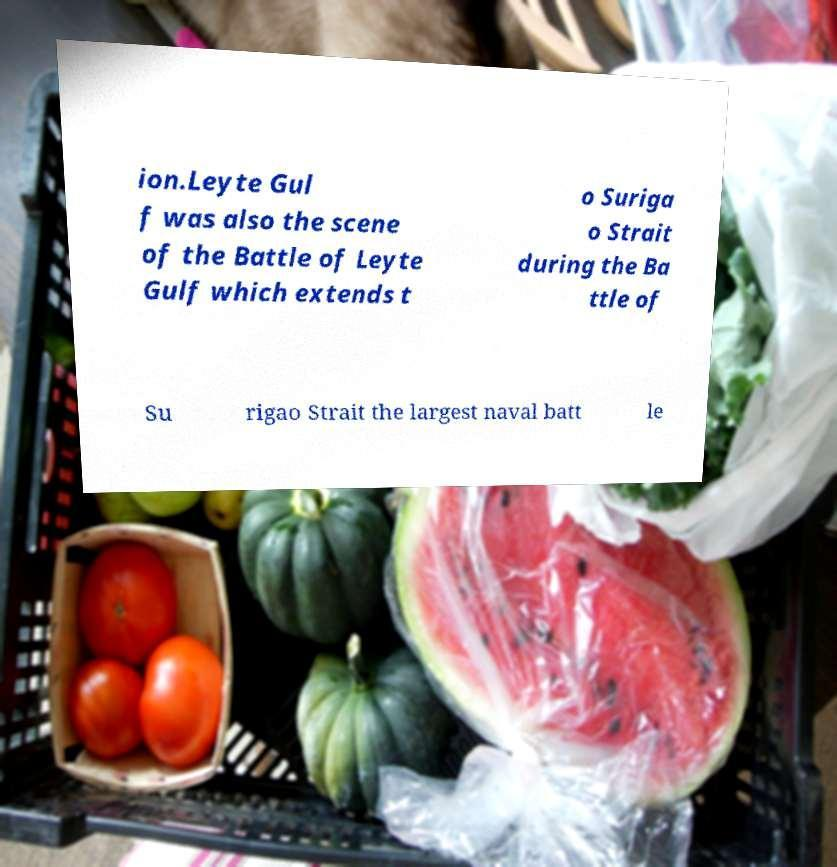Please identify and transcribe the text found in this image. ion.Leyte Gul f was also the scene of the Battle of Leyte Gulf which extends t o Suriga o Strait during the Ba ttle of Su rigao Strait the largest naval batt le 